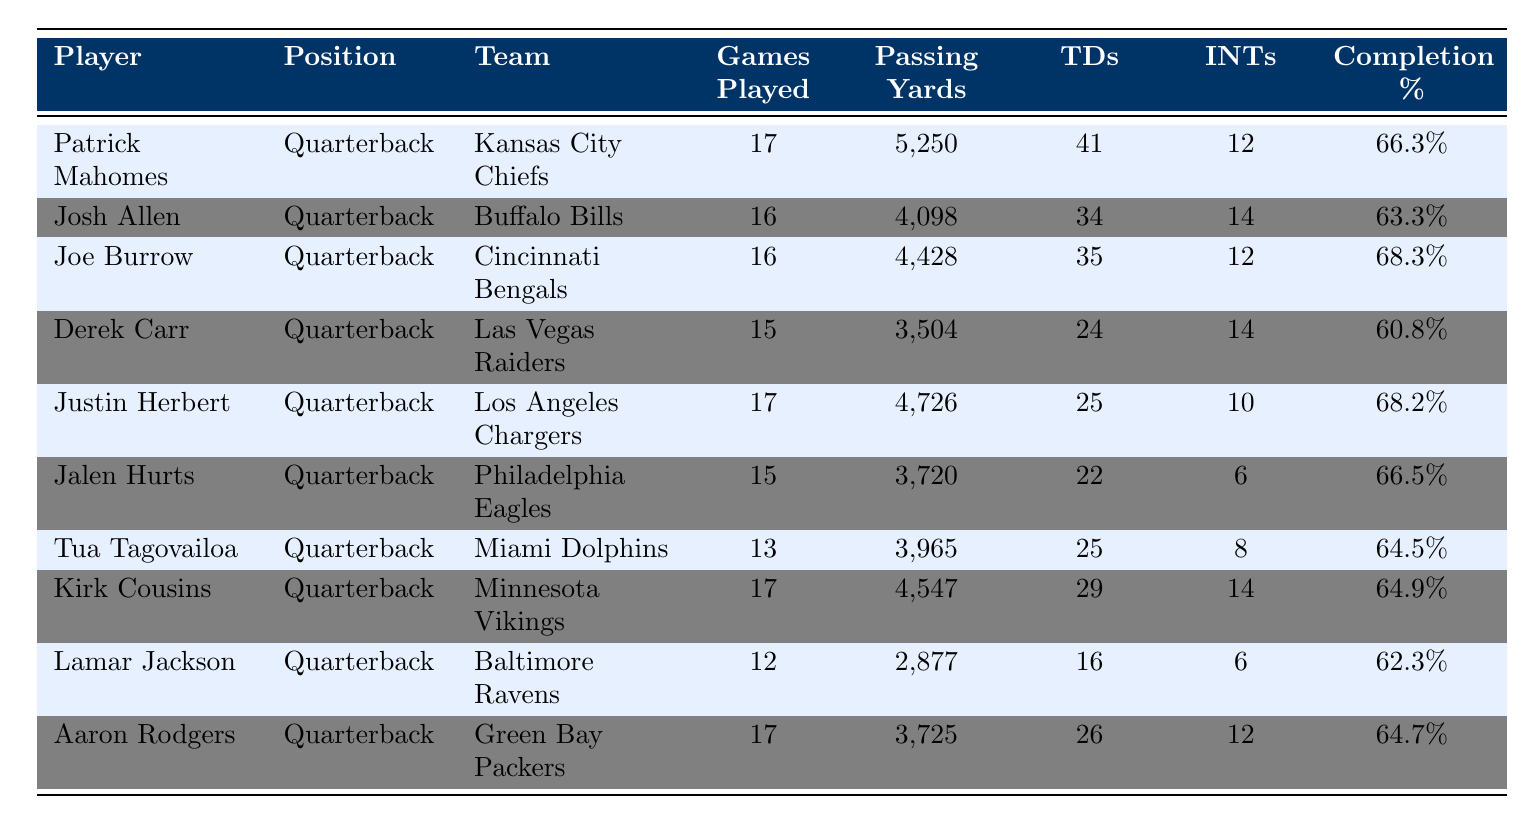What is the total number of touchdowns scored by all players listed in the table? To find the total number of touchdowns, add the touchdowns scored by each player: 41 (Mahomes) + 34 (Allen) + 35 (Burrow) + 24 (Carr) + 25 (Herbert) + 22 (Hurts) + 25 (Tagovailoa) + 29 (Cousins) + 16 (Jackson) + 26 (Rodgers) =  307 total touchdowns.
Answer: 307 Which player had the highest completion percentage? Look at the Completion Percentage column to find the highest value. Patrick Mahomes has a completion percentage of 66.3%, Joe Burrow has 68.3%, and Justin Herbert has 68.2%. Joe Burrow has the highest completion percentage of 68.3%.
Answer: Joe Burrow Who played the fewest games in the season? Review the Games Played column and find the player with the lowest number, which is Lamar Jackson with 12 games played.
Answer: Lamar Jackson What is the average number of passing yards for the quarterbacks listed? Calculate the total passing yards: 5250 + 4098 + 4428 + 3504 + 4726 + 3720 + 3965 + 4547 + 2877 + 3725 = 41830. Divide by the number of players (10), so 41830 / 10 = 4183.
Answer: 4183 Did Jalen Hurts throw more interceptions or touchdowns? Check the Interceptions and Touchdowns columns for Jalen Hurts. He threw 22 touchdowns and 6 interceptions. Since 22 > 6, he had more touchdowns than interceptions.
Answer: Yes Which quarterback had the most passing yards and what was the difference in passing yards between him and the player with the second-most yards? Patrick Mahomes had the most passing yards with 5250. The second-most is Joe Burrow with 4428. The difference is 5250 - 4428 = 822 yards.
Answer: 822 Which player had the best touchdown to interception ratio? For each player, divide the number of touchdowns by the number of interceptions. The ratios are as follows: Mahomes (3.42), Allen (2.43), Burrow (2.92), Carr (1.71), Herbert (2.50), Hurts (3.67), Tagovailoa (3.13), Cousins (2.07), Jackson (2.67), Rodgers (2.17). Jalen Hurts has the highest ratio of 3.67.
Answer: Jalen Hurts Identify the team with the quarterback who threw the most interceptions. The quarterback with the most interceptions is Derek Carr, who threw 14 interceptions for the Las Vegas Raiders.
Answer: Las Vegas Raiders How many quarterbacks had a completion percentage higher than 65%? Review the Completion Percentage column and count the players with percentages above 65%. They are Mahomes (66.3%), Burrow (68.3%), Herbert (68.2%), Hurts (66.5%), and Tagovailoa (64.5%). Four quarterbacks had a completion percentage higher than 65%.
Answer: 5 Which quarterback had the lowest touchdown count? Check the Touchdowns column to find the lowest number of touchdowns. Derek Carr had 24 touchdowns, which is the lowest in the list.
Answer: Derek Carr 